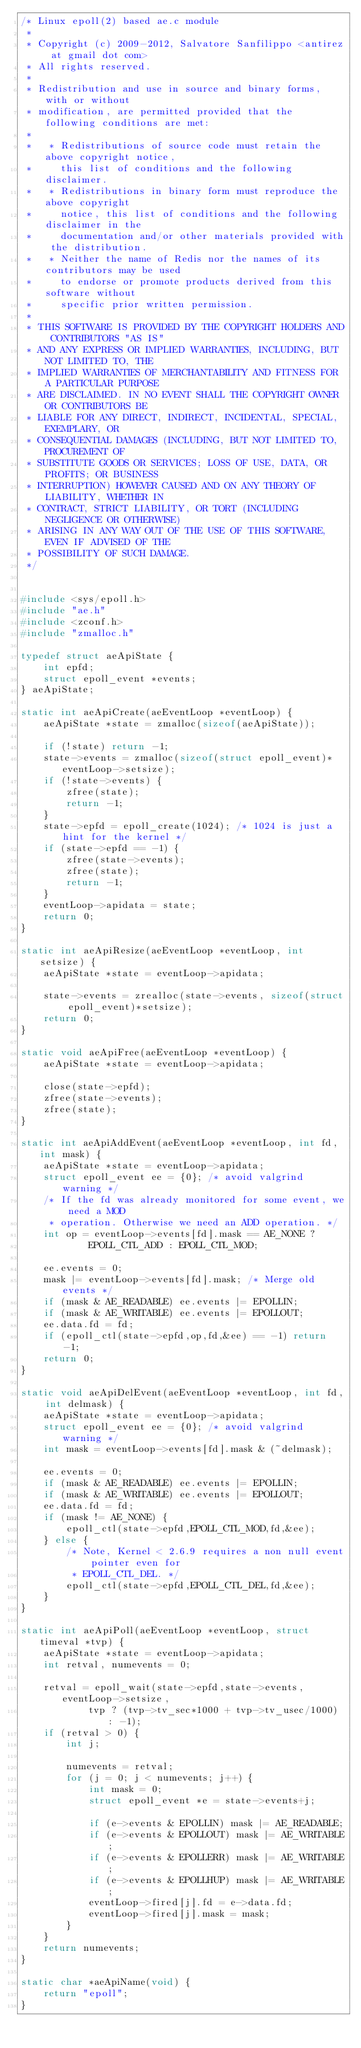<code> <loc_0><loc_0><loc_500><loc_500><_C_>/* Linux epoll(2) based ae.c module
 *
 * Copyright (c) 2009-2012, Salvatore Sanfilippo <antirez at gmail dot com>
 * All rights reserved.
 *
 * Redistribution and use in source and binary forms, with or without
 * modification, are permitted provided that the following conditions are met:
 *
 *   * Redistributions of source code must retain the above copyright notice,
 *     this list of conditions and the following disclaimer.
 *   * Redistributions in binary form must reproduce the above copyright
 *     notice, this list of conditions and the following disclaimer in the
 *     documentation and/or other materials provided with the distribution.
 *   * Neither the name of Redis nor the names of its contributors may be used
 *     to endorse or promote products derived from this software without
 *     specific prior written permission.
 *
 * THIS SOFTWARE IS PROVIDED BY THE COPYRIGHT HOLDERS AND CONTRIBUTORS "AS IS"
 * AND ANY EXPRESS OR IMPLIED WARRANTIES, INCLUDING, BUT NOT LIMITED TO, THE
 * IMPLIED WARRANTIES OF MERCHANTABILITY AND FITNESS FOR A PARTICULAR PURPOSE
 * ARE DISCLAIMED. IN NO EVENT SHALL THE COPYRIGHT OWNER OR CONTRIBUTORS BE
 * LIABLE FOR ANY DIRECT, INDIRECT, INCIDENTAL, SPECIAL, EXEMPLARY, OR
 * CONSEQUENTIAL DAMAGES (INCLUDING, BUT NOT LIMITED TO, PROCUREMENT OF
 * SUBSTITUTE GOODS OR SERVICES; LOSS OF USE, DATA, OR PROFITS; OR BUSINESS
 * INTERRUPTION) HOWEVER CAUSED AND ON ANY THEORY OF LIABILITY, WHETHER IN
 * CONTRACT, STRICT LIABILITY, OR TORT (INCLUDING NEGLIGENCE OR OTHERWISE)
 * ARISING IN ANY WAY OUT OF THE USE OF THIS SOFTWARE, EVEN IF ADVISED OF THE
 * POSSIBILITY OF SUCH DAMAGE.
 */


#include <sys/epoll.h>
#include "ae.h"
#include <zconf.h>
#include "zmalloc.h"

typedef struct aeApiState {
    int epfd;
    struct epoll_event *events;
} aeApiState;

static int aeApiCreate(aeEventLoop *eventLoop) {
    aeApiState *state = zmalloc(sizeof(aeApiState));

    if (!state) return -1;
    state->events = zmalloc(sizeof(struct epoll_event)*eventLoop->setsize);
    if (!state->events) {
        zfree(state);
        return -1;
    }
    state->epfd = epoll_create(1024); /* 1024 is just a hint for the kernel */
    if (state->epfd == -1) {
        zfree(state->events);
        zfree(state);
        return -1;
    }
    eventLoop->apidata = state;
    return 0;
}

static int aeApiResize(aeEventLoop *eventLoop, int setsize) {
    aeApiState *state = eventLoop->apidata;

    state->events = zrealloc(state->events, sizeof(struct epoll_event)*setsize);
    return 0;
}

static void aeApiFree(aeEventLoop *eventLoop) {
    aeApiState *state = eventLoop->apidata;

    close(state->epfd);
    zfree(state->events);
    zfree(state);
}

static int aeApiAddEvent(aeEventLoop *eventLoop, int fd, int mask) {
    aeApiState *state = eventLoop->apidata;
    struct epoll_event ee = {0}; /* avoid valgrind warning */
    /* If the fd was already monitored for some event, we need a MOD
     * operation. Otherwise we need an ADD operation. */
    int op = eventLoop->events[fd].mask == AE_NONE ?
            EPOLL_CTL_ADD : EPOLL_CTL_MOD;

    ee.events = 0;
    mask |= eventLoop->events[fd].mask; /* Merge old events */
    if (mask & AE_READABLE) ee.events |= EPOLLIN;
    if (mask & AE_WRITABLE) ee.events |= EPOLLOUT;
    ee.data.fd = fd;
    if (epoll_ctl(state->epfd,op,fd,&ee) == -1) return -1;
    return 0;
}

static void aeApiDelEvent(aeEventLoop *eventLoop, int fd, int delmask) {
    aeApiState *state = eventLoop->apidata;
    struct epoll_event ee = {0}; /* avoid valgrind warning */
    int mask = eventLoop->events[fd].mask & (~delmask);

    ee.events = 0;
    if (mask & AE_READABLE) ee.events |= EPOLLIN;
    if (mask & AE_WRITABLE) ee.events |= EPOLLOUT;
    ee.data.fd = fd;
    if (mask != AE_NONE) {
        epoll_ctl(state->epfd,EPOLL_CTL_MOD,fd,&ee);
    } else {
        /* Note, Kernel < 2.6.9 requires a non null event pointer even for
         * EPOLL_CTL_DEL. */
        epoll_ctl(state->epfd,EPOLL_CTL_DEL,fd,&ee);
    }
}

static int aeApiPoll(aeEventLoop *eventLoop, struct timeval *tvp) {
    aeApiState *state = eventLoop->apidata;
    int retval, numevents = 0;

    retval = epoll_wait(state->epfd,state->events,eventLoop->setsize,
            tvp ? (tvp->tv_sec*1000 + tvp->tv_usec/1000) : -1);
    if (retval > 0) {
        int j;

        numevents = retval;
        for (j = 0; j < numevents; j++) {
            int mask = 0;
            struct epoll_event *e = state->events+j;

            if (e->events & EPOLLIN) mask |= AE_READABLE;
            if (e->events & EPOLLOUT) mask |= AE_WRITABLE;
            if (e->events & EPOLLERR) mask |= AE_WRITABLE;
            if (e->events & EPOLLHUP) mask |= AE_WRITABLE;
            eventLoop->fired[j].fd = e->data.fd;
            eventLoop->fired[j].mask = mask;
        }
    }
    return numevents;
}

static char *aeApiName(void) {
    return "epoll";
}
</code> 